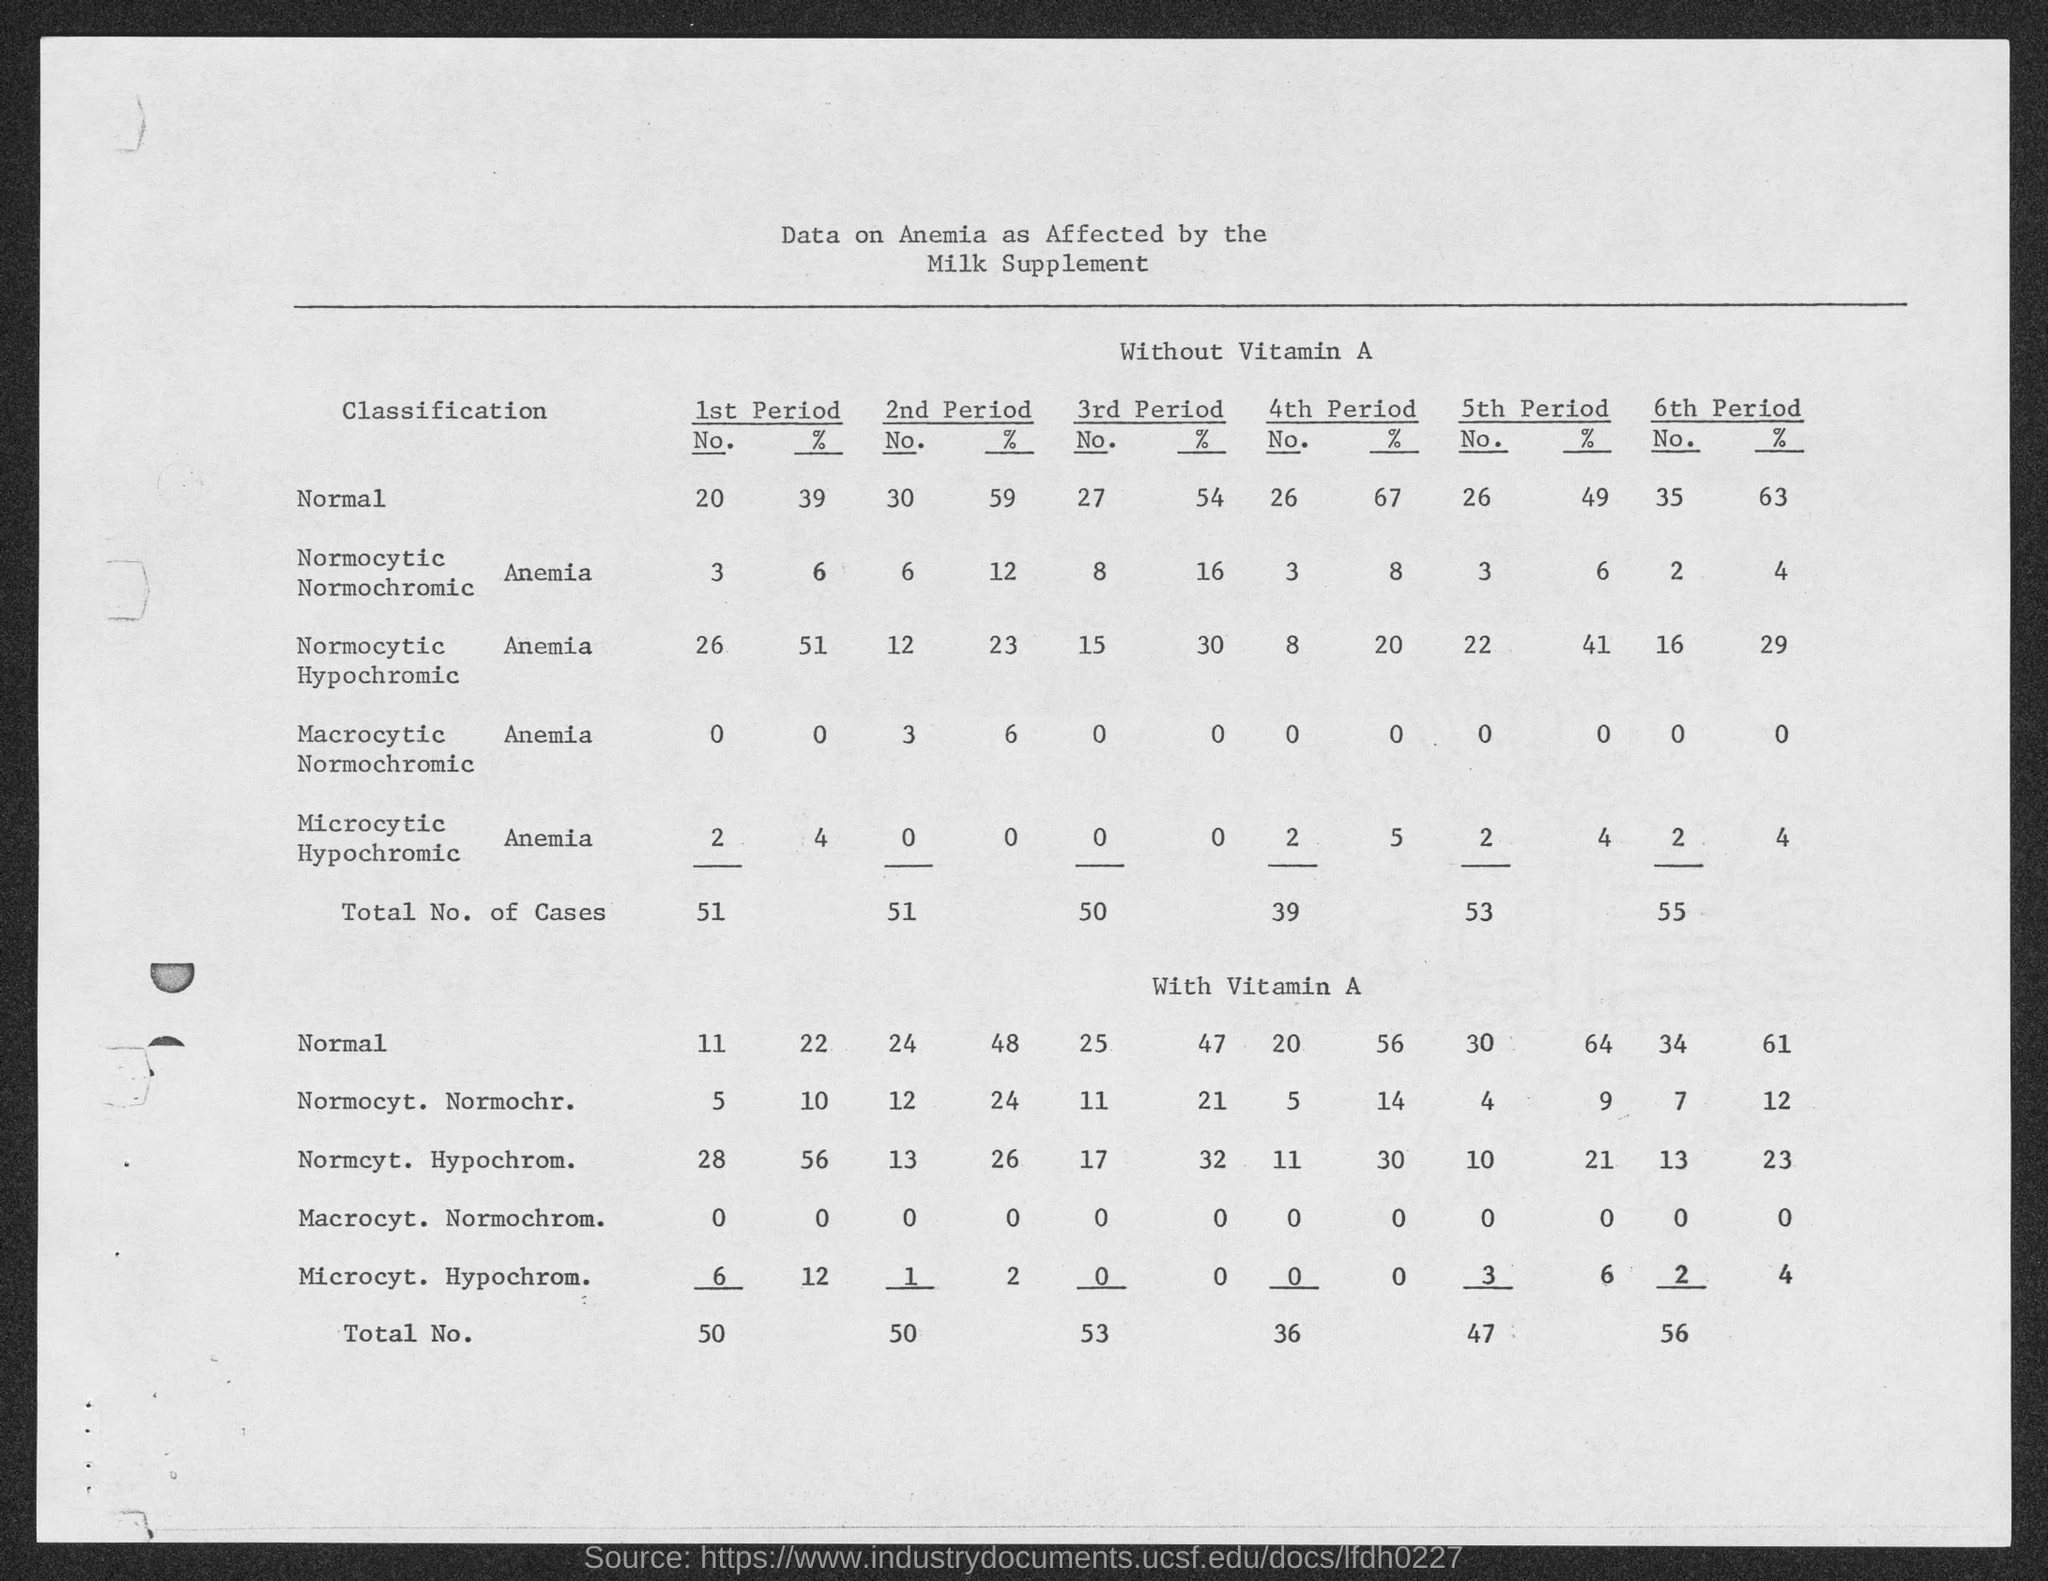Point out several critical features in this image. The table presents the title of the table, which provides data on anemia and its effect on the consumption of milk supplements. 